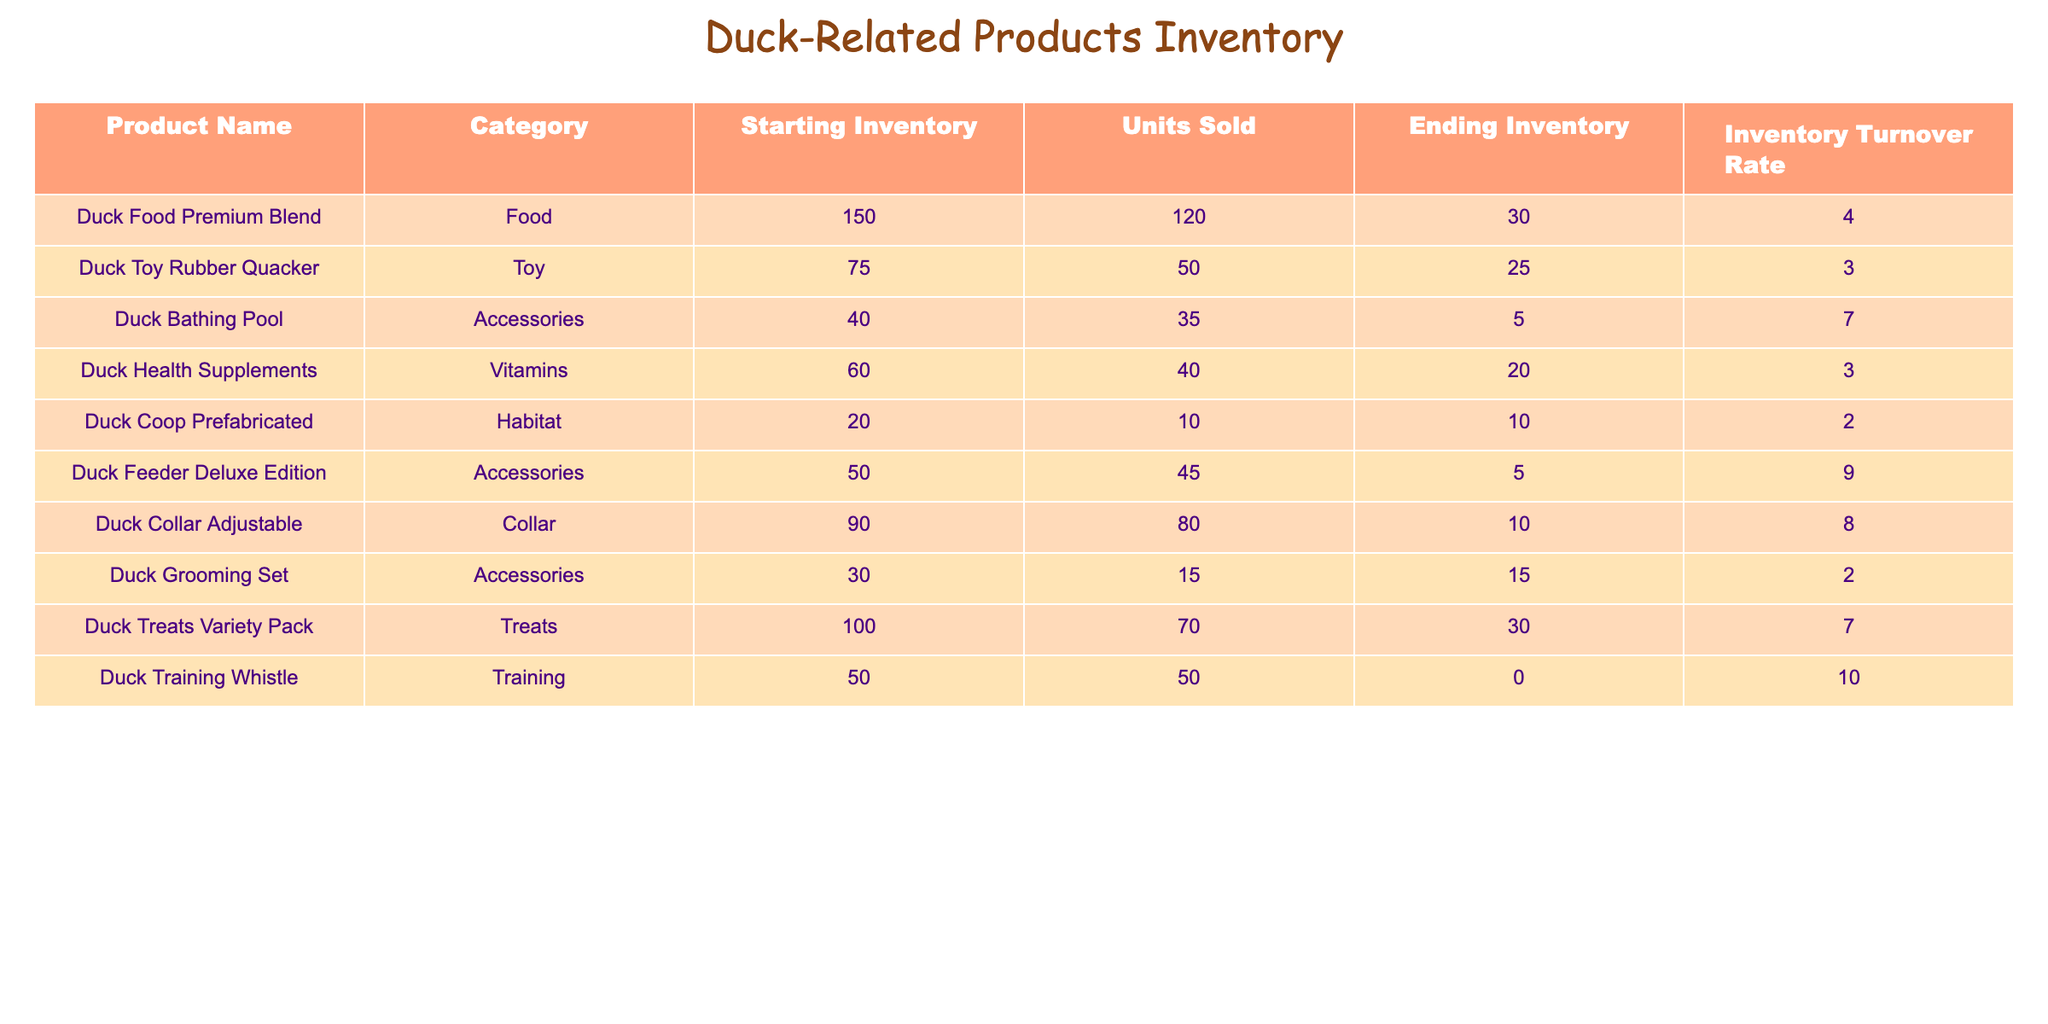What is the product with the highest inventory turnover rate? The inventory turnover rates for the products are listed in the table. The highest value is 10.0 for the Duck Training Whistle.
Answer: Duck Training Whistle What category does the Duck Collar Adjustable belong to? The table shows the categories alongside each product. The Duck Collar Adjustable falls under the Collar category.
Answer: Collar How many units of Duck Food Premium Blend are remaining in inventory? The Ending Inventory column provides the current stock. For Duck Food Premium Blend, the ending inventory is 30 units.
Answer: 30 What is the total starting inventory for all duck-related products? We sum the Starting Inventory across all products: 150 + 75 + 40 + 60 + 20 + 50 + 90 + 30 + 100 + 50 = 665.
Answer: 665 Is the inventory turnover rate for the Duck Health Supplements greater than the Duck Toy Rubber Quacker? We compare the turnover rates: Duck Health Supplements has a rate of 3.0, while Duck Toy Rubber Quacker has a rate of 3.0. Since both rates are equal, the answer is no.
Answer: No What is the average inventory turnover rate for all products? We calculate the average of the turnover rates. The rates are 4.0, 3.0, 7.0, 3.0, 2.0, 9.0, 8.0, 2.0, 7.0, and 10.0, summing to 55 and dividing by 10, which gives an average of 5.5.
Answer: 5.5 Which product had the lowest ending inventory? By looking at the Ending Inventory column, we see the Duck Training Whistle has an ending inventory of 0, which is the lowest.
Answer: Duck Training Whistle Are all accessories products selling faster than their starting inventory? We examine the turnover rates for accessories. The Duck Bathing Pool has a turnover rate of 7.0, Duck Feeder Deluxe Edition has 9.0, and Duck Grooming Set has 2.0, indicating that the Duck Grooming Set does not exceed its starting inventory. Therefore, the answer is no.
Answer: No How many more units of Duck Toy Rubber Quacker were sold compared to Duck Coop Prefabricated? We subtract the Units Sold for Duck Coop Prefabricated (10) from Duck Toy Rubber Quacker (50). The difference is 50 - 10 = 40.
Answer: 40 